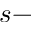Convert formula to latex. <formula><loc_0><loc_0><loc_500><loc_500>s -</formula> 